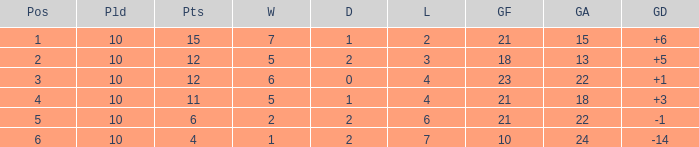Can you tell me the lowest Played that has the Position larger than 2, and the Draws smaller than 2, and the Goals against smaller than 18? None. Could you parse the entire table? {'header': ['Pos', 'Pld', 'Pts', 'W', 'D', 'L', 'GF', 'GA', 'GD'], 'rows': [['1', '10', '15', '7', '1', '2', '21', '15', '+6'], ['2', '10', '12', '5', '2', '3', '18', '13', '+5'], ['3', '10', '12', '6', '0', '4', '23', '22', '+1'], ['4', '10', '11', '5', '1', '4', '21', '18', '+3'], ['5', '10', '6', '2', '2', '6', '21', '22', '-1'], ['6', '10', '4', '1', '2', '7', '10', '24', '-14']]} 